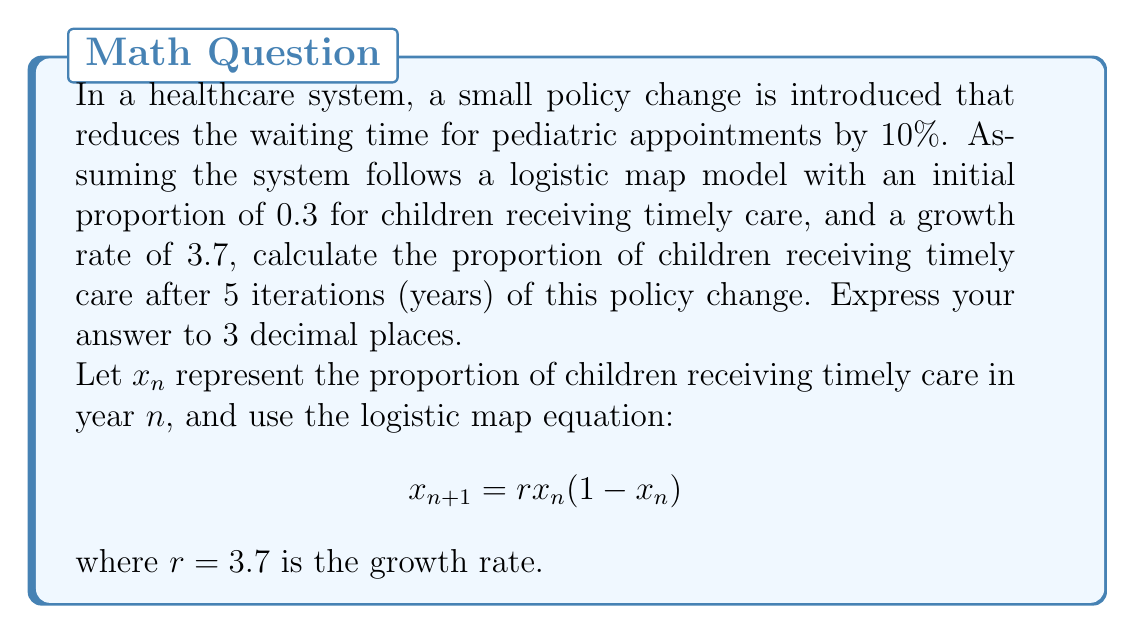Can you solve this math problem? To solve this problem, we'll use the logistic map equation iteratively:

1. Initial condition: $x_0 = 0.3 + (0.1 \times 0.3) = 0.33$ (10% increase from 0.3)

2. Iteration 1:
   $x_1 = 3.7 \times 0.33 \times (1 - 0.33) = 0.818910$

3. Iteration 2:
   $x_2 = 3.7 \times 0.818910 \times (1 - 0.818910) = 0.551249$

4. Iteration 3:
   $x_3 = 3.7 \times 0.551249 \times (1 - 0.551249) = 0.915214$

5. Iteration 4:
   $x_4 = 3.7 \times 0.915214 \times (1 - 0.915214) = 0.287325$

6. Iteration 5:
   $x_5 = 3.7 \times 0.287325 \times (1 - 0.287325) = 0.758614$

The proportion of children receiving timely care after 5 iterations is 0.758614, which rounded to 3 decimal places is 0.759.
Answer: 0.759 